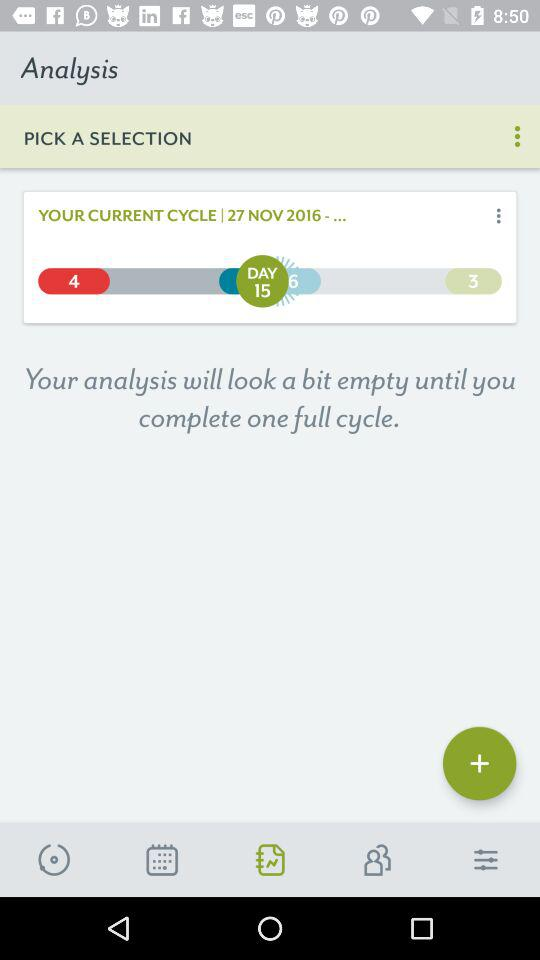How many notifications are there in "contacts"?
When the provided information is insufficient, respond with <no answer>. <no answer> 